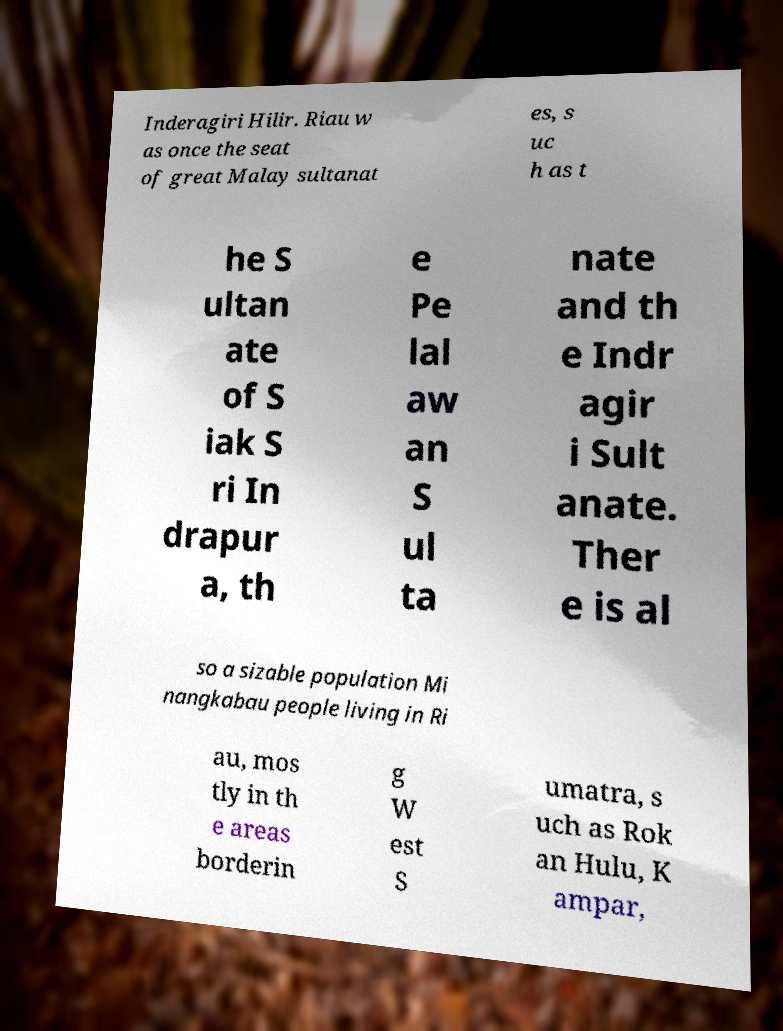For documentation purposes, I need the text within this image transcribed. Could you provide that? Inderagiri Hilir. Riau w as once the seat of great Malay sultanat es, s uc h as t he S ultan ate of S iak S ri In drapur a, th e Pe lal aw an S ul ta nate and th e Indr agir i Sult anate. Ther e is al so a sizable population Mi nangkabau people living in Ri au, mos tly in th e areas borderin g W est S umatra, s uch as Rok an Hulu, K ampar, 